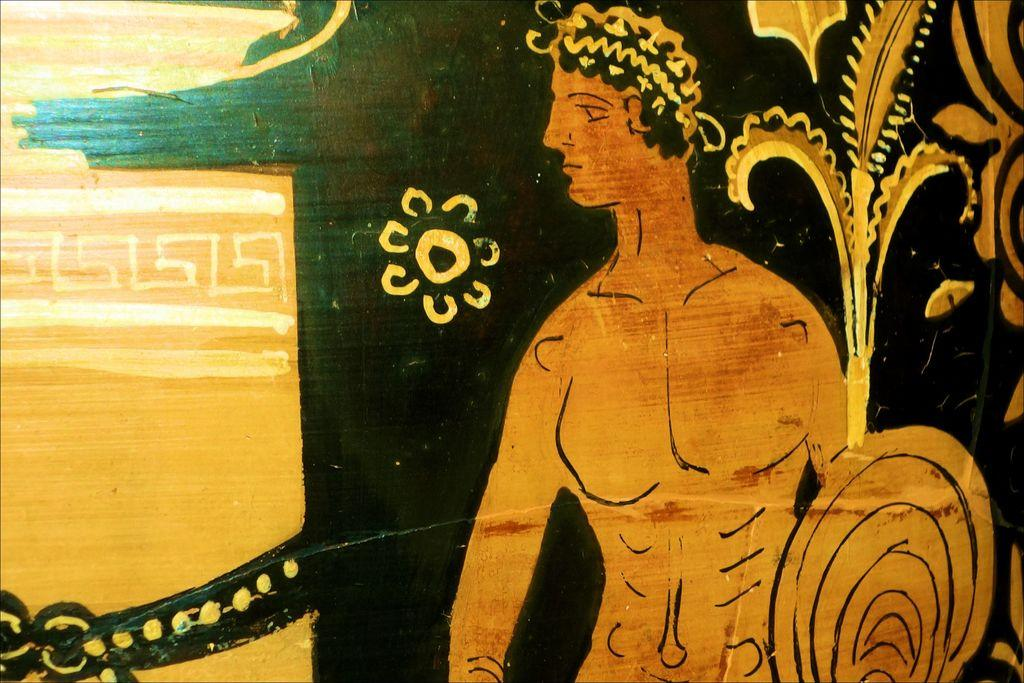What type of artwork is shown in the image? The image is a painting. What is the main subject of the painting? There is a depiction of a person in the painting. What type of weather is depicted in the painting? The provided facts do not mention any weather conditions in the painting, so it cannot be determined from the image. 